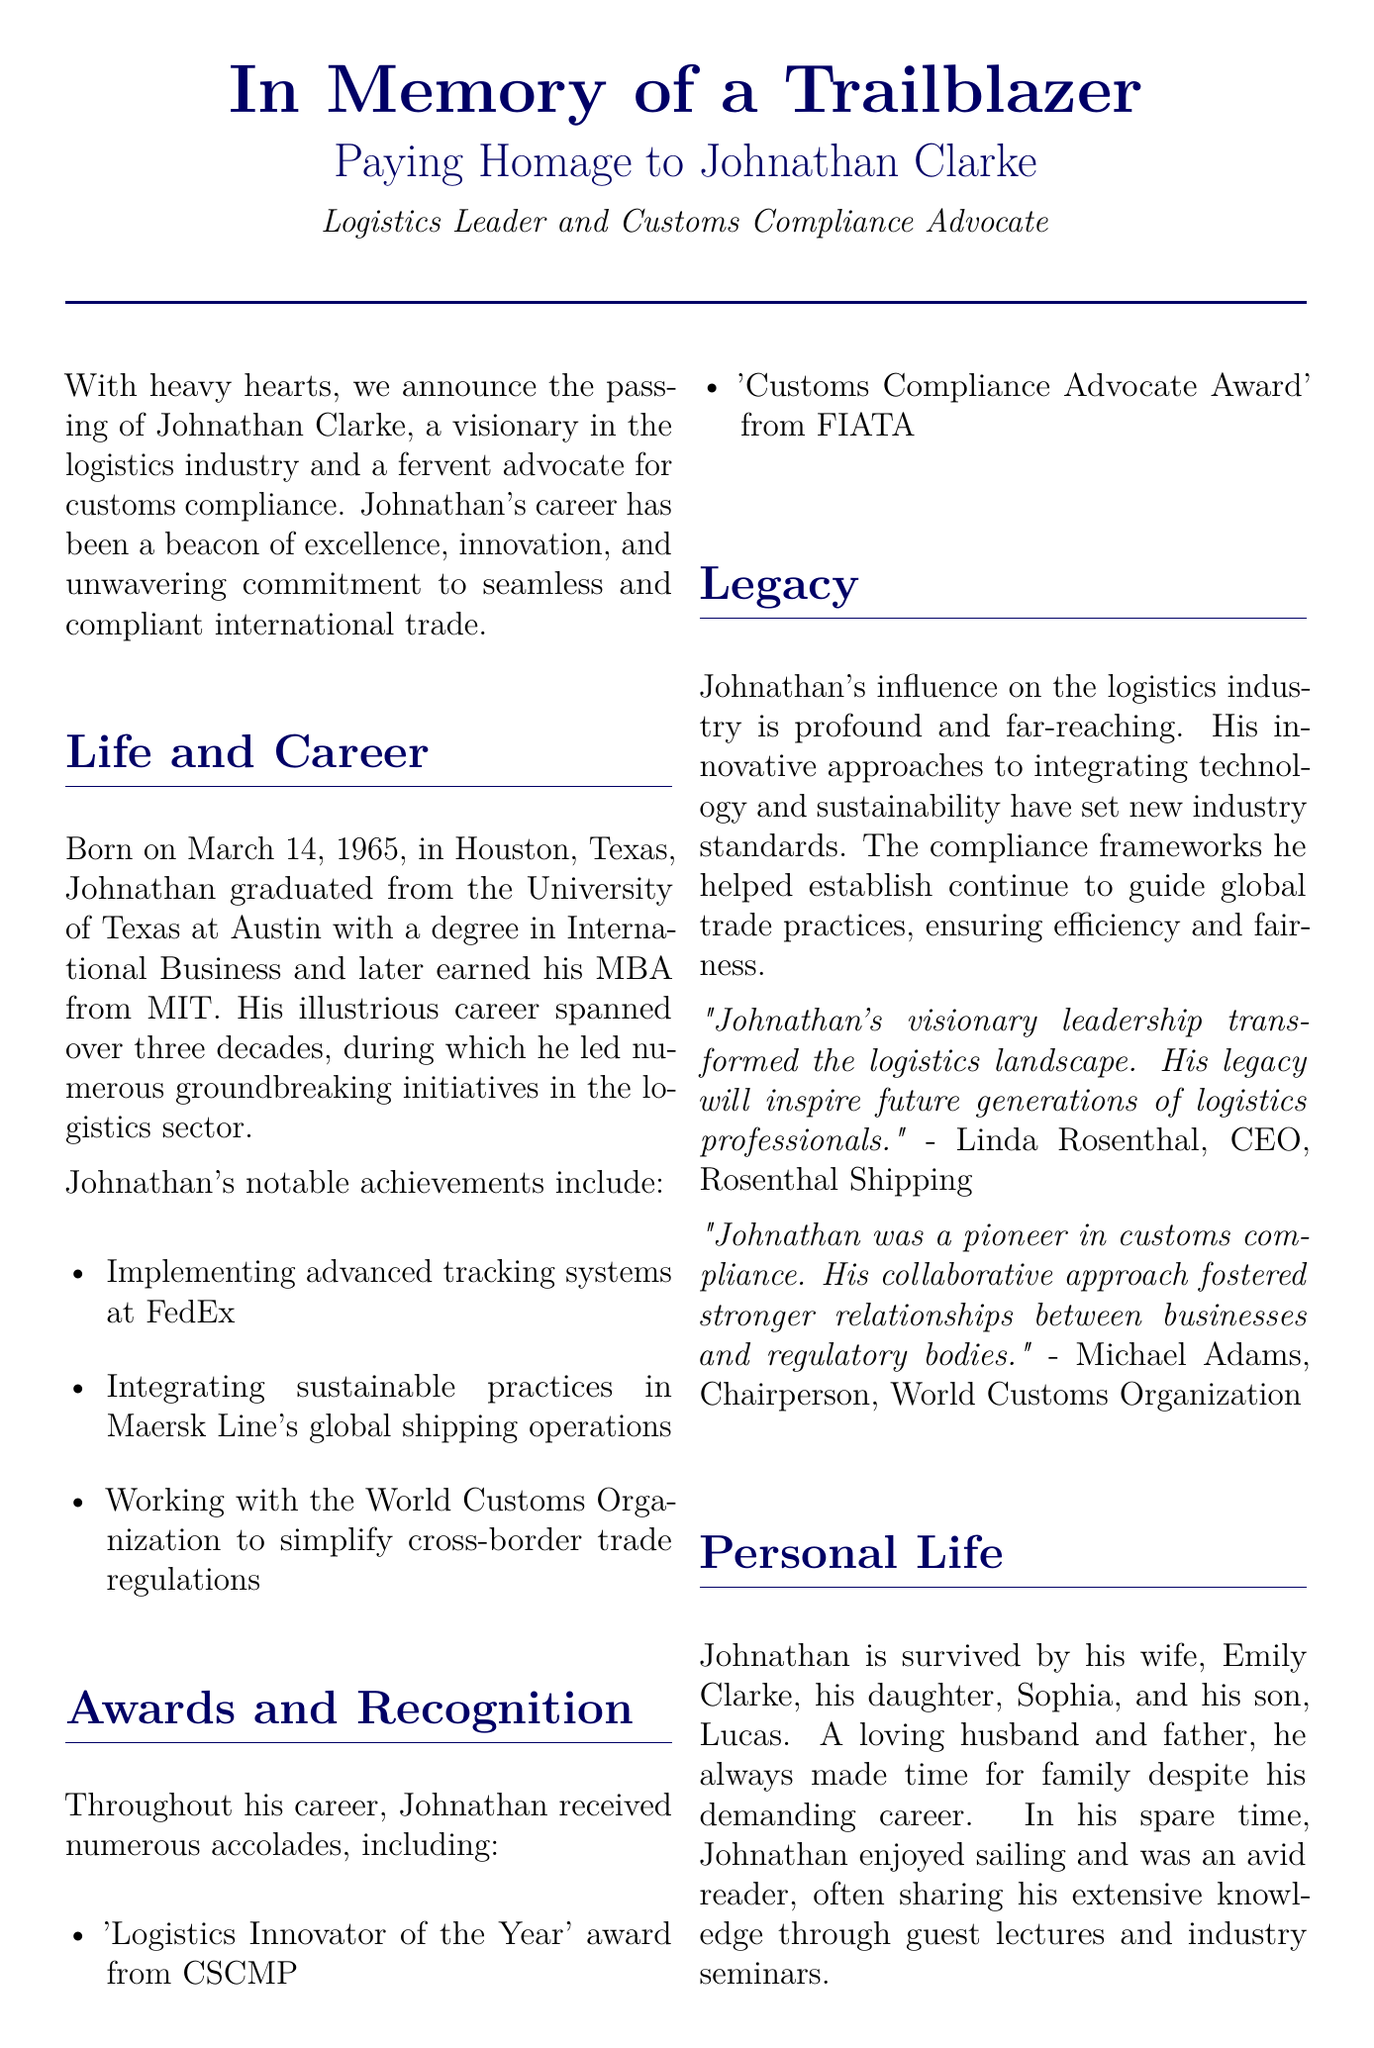What is the name of the logistics leader being honored? The name of the logistics leader being honored is mentioned in the title of the document.
Answer: Johnathan Clarke When was Johnathan Clarke born? The birth date of Johnathan Clarke is specified in the Life and Career section of the document.
Answer: March 14, 1965 What degree did Johnathan Clarke earn from the University of Texas at Austin? The document states the degree he earned as part of his educational background.
Answer: International Business Which award did he receive from CSCMP? The specific award mentioned in the document from CSCMP is highlighted in the Awards and Recognition section.
Answer: 'Logistics Innovator of the Year' What was one of Johnathan's notable achievements regarding customs? This achievement is detailed in the Life and Career section and highlights his contribution to customs regulation.
Answer: Simplifying cross-border trade regulations How many children did Johnathan Clarke have? The document provides details about his family in the Personal Life section, including the number of children he had.
Answer: Two What was Johnathan's approach to logistics as highlighted in his legacy? The text discusses his approach in the Legacy section, indicating his method or philosophy.
Answer: Integrating technology and sustainability Which organization awarded Johnathan the 'Customs Compliance Advocate Award'? The specific organization that presented this award is mentioned in the Awards and Recognition section.
Answer: FIATA 